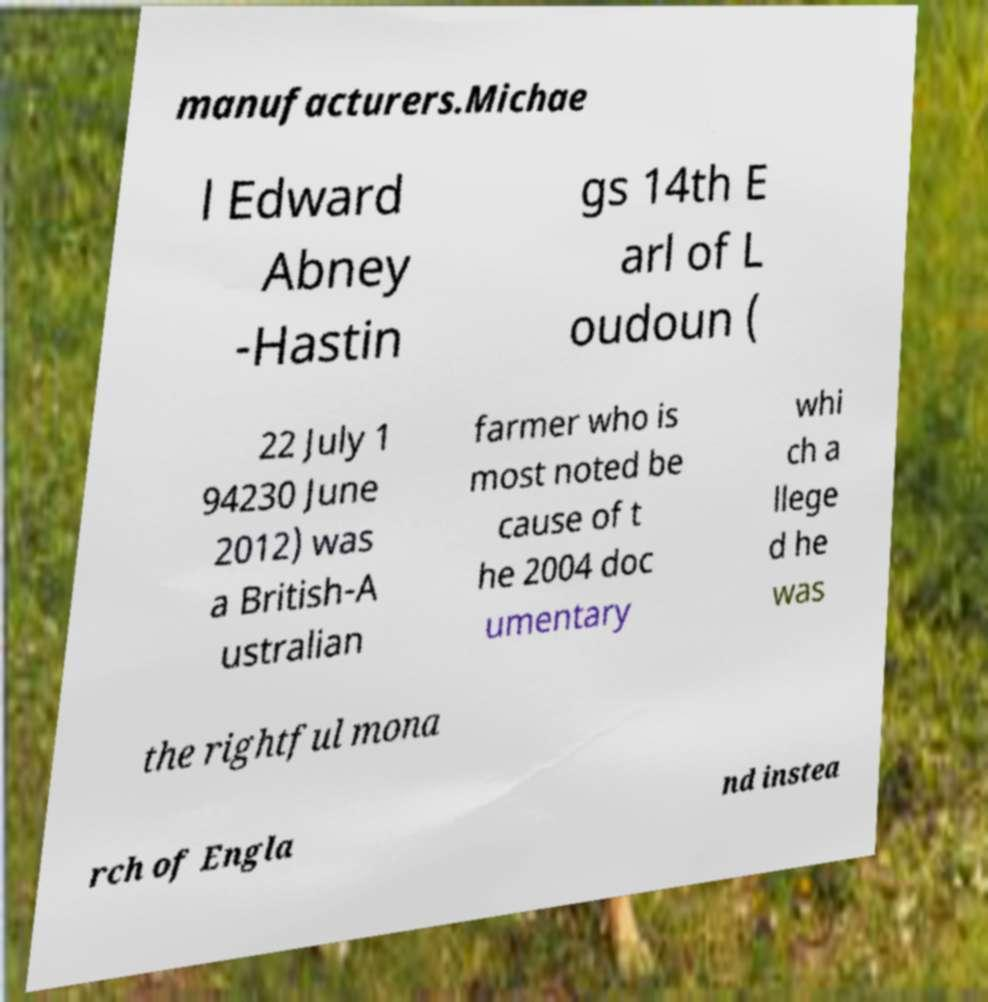There's text embedded in this image that I need extracted. Can you transcribe it verbatim? manufacturers.Michae l Edward Abney -Hastin gs 14th E arl of L oudoun ( 22 July 1 94230 June 2012) was a British-A ustralian farmer who is most noted be cause of t he 2004 doc umentary whi ch a llege d he was the rightful mona rch of Engla nd instea 